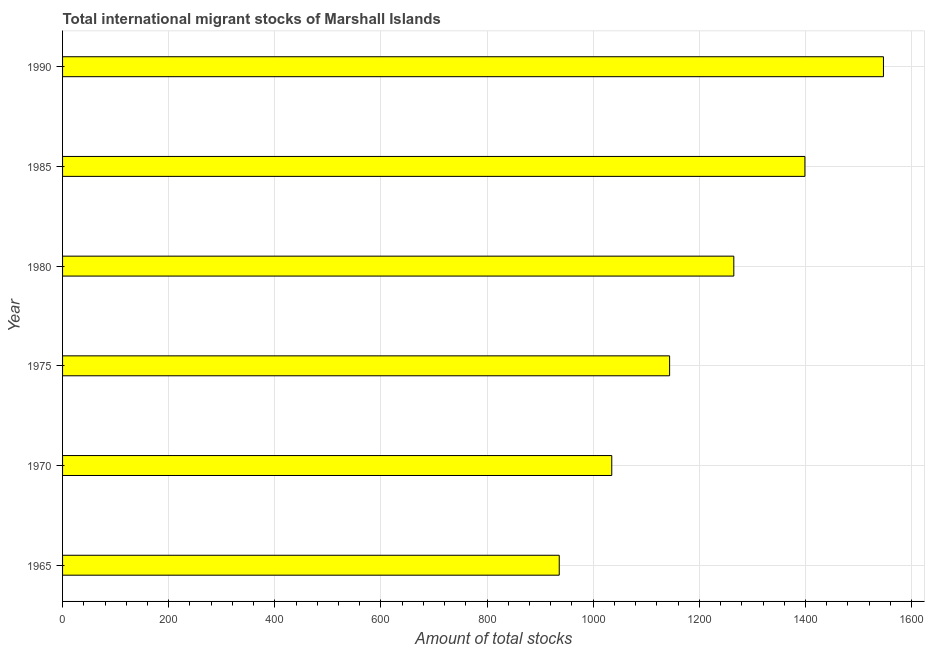Does the graph contain any zero values?
Give a very brief answer. No. What is the title of the graph?
Your answer should be very brief. Total international migrant stocks of Marshall Islands. What is the label or title of the X-axis?
Give a very brief answer. Amount of total stocks. What is the total number of international migrant stock in 1970?
Give a very brief answer. 1035. Across all years, what is the maximum total number of international migrant stock?
Keep it short and to the point. 1547. Across all years, what is the minimum total number of international migrant stock?
Provide a short and direct response. 936. In which year was the total number of international migrant stock maximum?
Offer a terse response. 1990. In which year was the total number of international migrant stock minimum?
Offer a terse response. 1965. What is the sum of the total number of international migrant stock?
Keep it short and to the point. 7326. What is the difference between the total number of international migrant stock in 1965 and 1990?
Offer a terse response. -611. What is the average total number of international migrant stock per year?
Provide a short and direct response. 1221. What is the median total number of international migrant stock?
Make the answer very short. 1204.5. In how many years, is the total number of international migrant stock greater than 1360 ?
Make the answer very short. 2. What is the ratio of the total number of international migrant stock in 1985 to that in 1990?
Make the answer very short. 0.9. Is the total number of international migrant stock in 1970 less than that in 1980?
Provide a short and direct response. Yes. Is the difference between the total number of international migrant stock in 1975 and 1980 greater than the difference between any two years?
Give a very brief answer. No. What is the difference between the highest and the second highest total number of international migrant stock?
Ensure brevity in your answer.  148. Is the sum of the total number of international migrant stock in 1970 and 1980 greater than the maximum total number of international migrant stock across all years?
Provide a succinct answer. Yes. What is the difference between the highest and the lowest total number of international migrant stock?
Provide a short and direct response. 611. Are all the bars in the graph horizontal?
Give a very brief answer. Yes. What is the difference between two consecutive major ticks on the X-axis?
Your answer should be very brief. 200. Are the values on the major ticks of X-axis written in scientific E-notation?
Ensure brevity in your answer.  No. What is the Amount of total stocks of 1965?
Provide a succinct answer. 936. What is the Amount of total stocks of 1970?
Keep it short and to the point. 1035. What is the Amount of total stocks in 1975?
Provide a succinct answer. 1144. What is the Amount of total stocks in 1980?
Give a very brief answer. 1265. What is the Amount of total stocks of 1985?
Offer a very short reply. 1399. What is the Amount of total stocks of 1990?
Give a very brief answer. 1547. What is the difference between the Amount of total stocks in 1965 and 1970?
Provide a short and direct response. -99. What is the difference between the Amount of total stocks in 1965 and 1975?
Provide a succinct answer. -208. What is the difference between the Amount of total stocks in 1965 and 1980?
Provide a succinct answer. -329. What is the difference between the Amount of total stocks in 1965 and 1985?
Your answer should be very brief. -463. What is the difference between the Amount of total stocks in 1965 and 1990?
Your answer should be very brief. -611. What is the difference between the Amount of total stocks in 1970 and 1975?
Provide a short and direct response. -109. What is the difference between the Amount of total stocks in 1970 and 1980?
Offer a very short reply. -230. What is the difference between the Amount of total stocks in 1970 and 1985?
Provide a short and direct response. -364. What is the difference between the Amount of total stocks in 1970 and 1990?
Your answer should be compact. -512. What is the difference between the Amount of total stocks in 1975 and 1980?
Make the answer very short. -121. What is the difference between the Amount of total stocks in 1975 and 1985?
Offer a very short reply. -255. What is the difference between the Amount of total stocks in 1975 and 1990?
Your response must be concise. -403. What is the difference between the Amount of total stocks in 1980 and 1985?
Provide a short and direct response. -134. What is the difference between the Amount of total stocks in 1980 and 1990?
Ensure brevity in your answer.  -282. What is the difference between the Amount of total stocks in 1985 and 1990?
Make the answer very short. -148. What is the ratio of the Amount of total stocks in 1965 to that in 1970?
Make the answer very short. 0.9. What is the ratio of the Amount of total stocks in 1965 to that in 1975?
Keep it short and to the point. 0.82. What is the ratio of the Amount of total stocks in 1965 to that in 1980?
Ensure brevity in your answer.  0.74. What is the ratio of the Amount of total stocks in 1965 to that in 1985?
Give a very brief answer. 0.67. What is the ratio of the Amount of total stocks in 1965 to that in 1990?
Offer a very short reply. 0.6. What is the ratio of the Amount of total stocks in 1970 to that in 1975?
Give a very brief answer. 0.91. What is the ratio of the Amount of total stocks in 1970 to that in 1980?
Make the answer very short. 0.82. What is the ratio of the Amount of total stocks in 1970 to that in 1985?
Provide a succinct answer. 0.74. What is the ratio of the Amount of total stocks in 1970 to that in 1990?
Make the answer very short. 0.67. What is the ratio of the Amount of total stocks in 1975 to that in 1980?
Your response must be concise. 0.9. What is the ratio of the Amount of total stocks in 1975 to that in 1985?
Your answer should be compact. 0.82. What is the ratio of the Amount of total stocks in 1975 to that in 1990?
Provide a succinct answer. 0.74. What is the ratio of the Amount of total stocks in 1980 to that in 1985?
Ensure brevity in your answer.  0.9. What is the ratio of the Amount of total stocks in 1980 to that in 1990?
Ensure brevity in your answer.  0.82. What is the ratio of the Amount of total stocks in 1985 to that in 1990?
Provide a short and direct response. 0.9. 